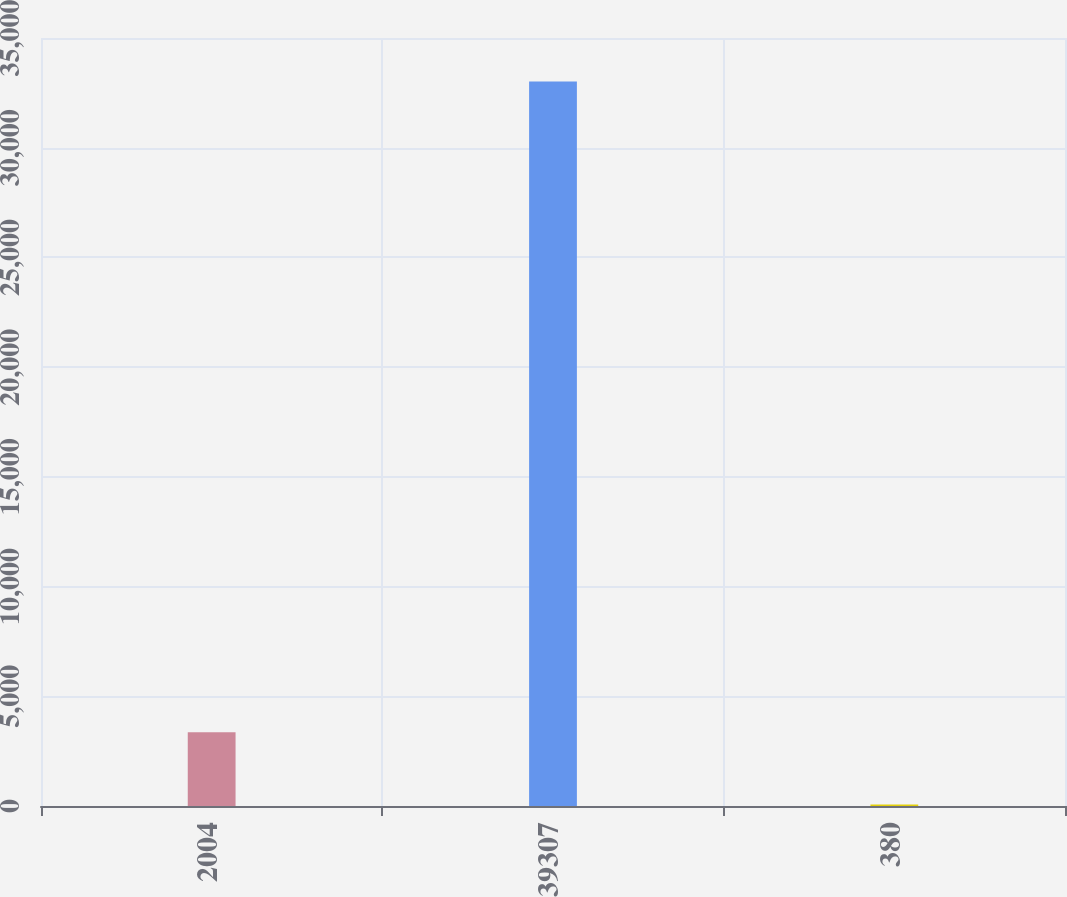Convert chart. <chart><loc_0><loc_0><loc_500><loc_500><bar_chart><fcel>2004<fcel>39307<fcel>380<nl><fcel>3360.8<fcel>33023<fcel>65<nl></chart> 